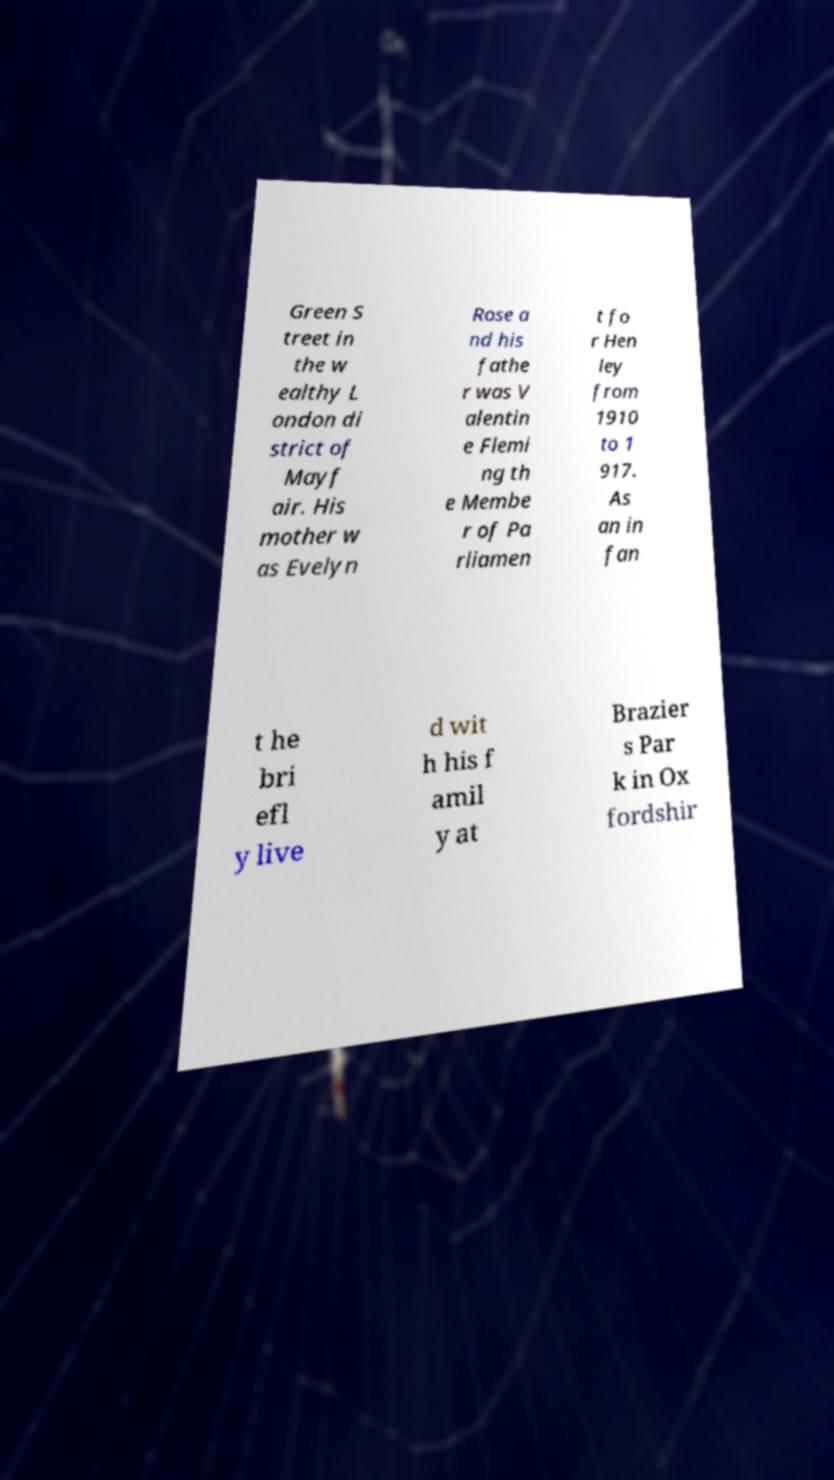Could you extract and type out the text from this image? Green S treet in the w ealthy L ondon di strict of Mayf air. His mother w as Evelyn Rose a nd his fathe r was V alentin e Flemi ng th e Membe r of Pa rliamen t fo r Hen ley from 1910 to 1 917. As an in fan t he bri efl y live d wit h his f amil y at Brazier s Par k in Ox fordshir 